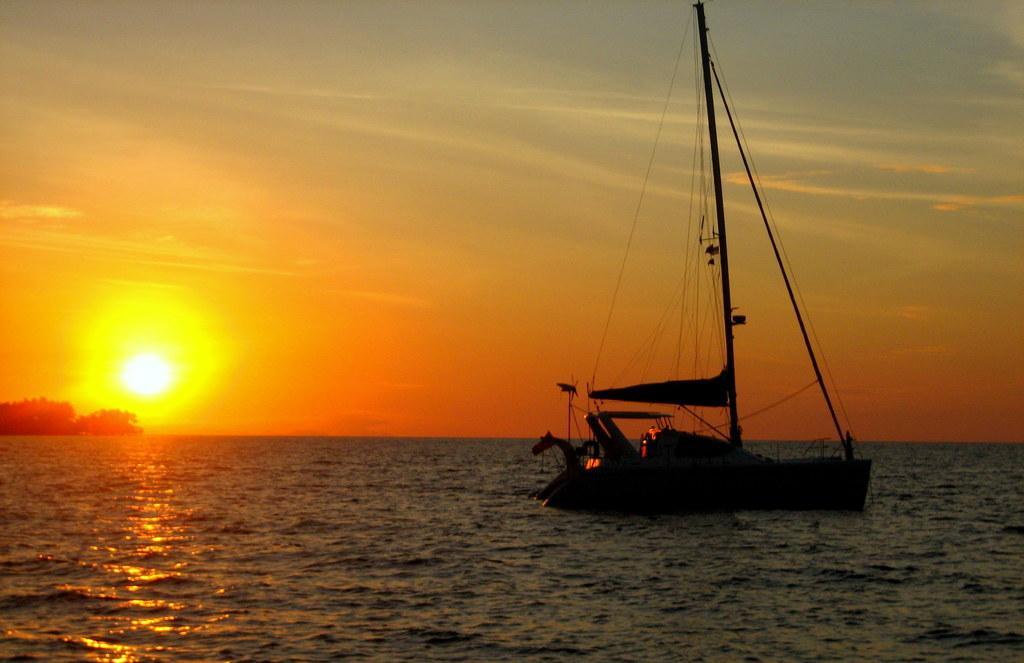Could you give a brief overview of what you see in this image? This image is taken during the sunset time. In this image we can see the boat on the surface of the river. We can also see the trees and also the sky in the background. 